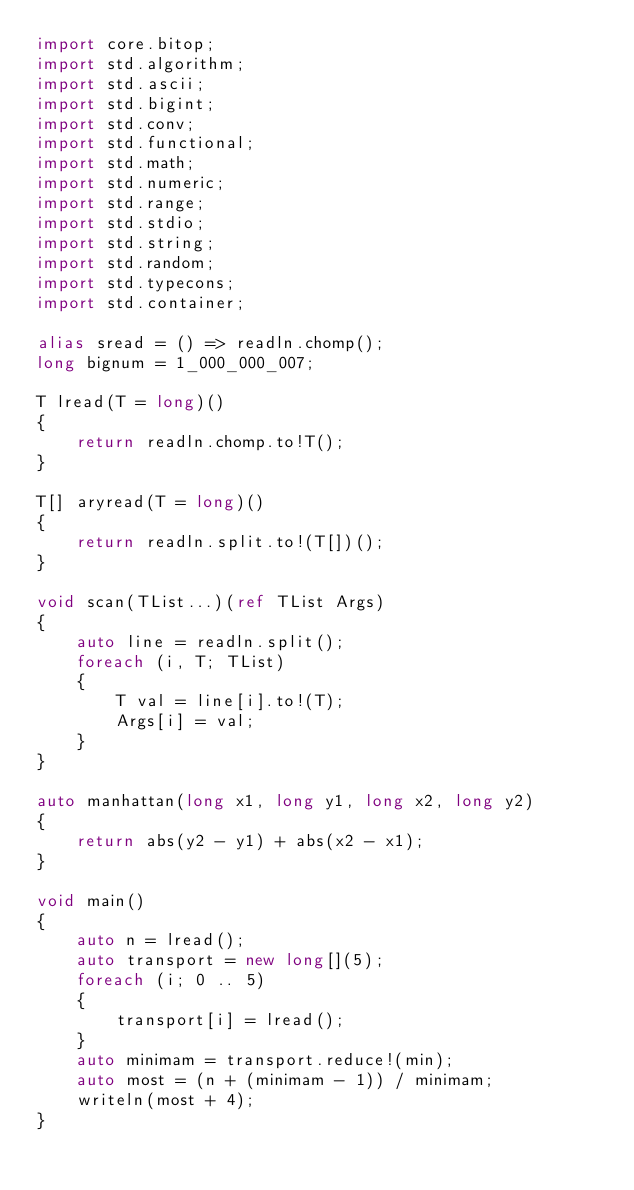<code> <loc_0><loc_0><loc_500><loc_500><_D_>import core.bitop;
import std.algorithm;
import std.ascii;
import std.bigint;
import std.conv;
import std.functional;
import std.math;
import std.numeric;
import std.range;
import std.stdio;
import std.string;
import std.random;
import std.typecons;
import std.container;

alias sread = () => readln.chomp();
long bignum = 1_000_000_007;

T lread(T = long)()
{
    return readln.chomp.to!T();
}

T[] aryread(T = long)()
{
    return readln.split.to!(T[])();
}

void scan(TList...)(ref TList Args)
{
    auto line = readln.split();
    foreach (i, T; TList)
    {
        T val = line[i].to!(T);
        Args[i] = val;
    }
}

auto manhattan(long x1, long y1, long x2, long y2)
{
    return abs(y2 - y1) + abs(x2 - x1);
}

void main()
{
    auto n = lread();
    auto transport = new long[](5);
    foreach (i; 0 .. 5)
    {
        transport[i] = lread();
    }
    auto minimam = transport.reduce!(min);
    auto most = (n + (minimam - 1)) / minimam;
    writeln(most + 4);
}
</code> 